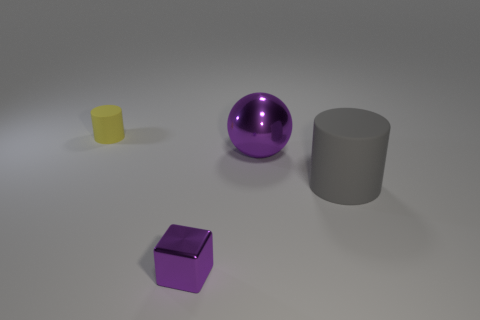Add 4 big brown cubes. How many objects exist? 8 Subtract all spheres. How many objects are left? 3 Add 3 large purple spheres. How many large purple spheres exist? 4 Subtract 0 green balls. How many objects are left? 4 Subtract all purple balls. Subtract all small cyan metal balls. How many objects are left? 3 Add 1 big gray cylinders. How many big gray cylinders are left? 2 